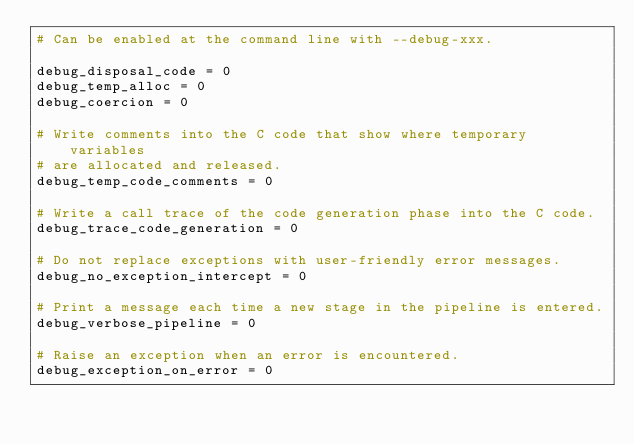<code> <loc_0><loc_0><loc_500><loc_500><_Python_># Can be enabled at the command line with --debug-xxx.

debug_disposal_code = 0
debug_temp_alloc = 0
debug_coercion = 0

# Write comments into the C code that show where temporary variables
# are allocated and released.
debug_temp_code_comments = 0

# Write a call trace of the code generation phase into the C code.
debug_trace_code_generation = 0

# Do not replace exceptions with user-friendly error messages.
debug_no_exception_intercept = 0

# Print a message each time a new stage in the pipeline is entered.
debug_verbose_pipeline = 0

# Raise an exception when an error is encountered.
debug_exception_on_error = 0
</code> 